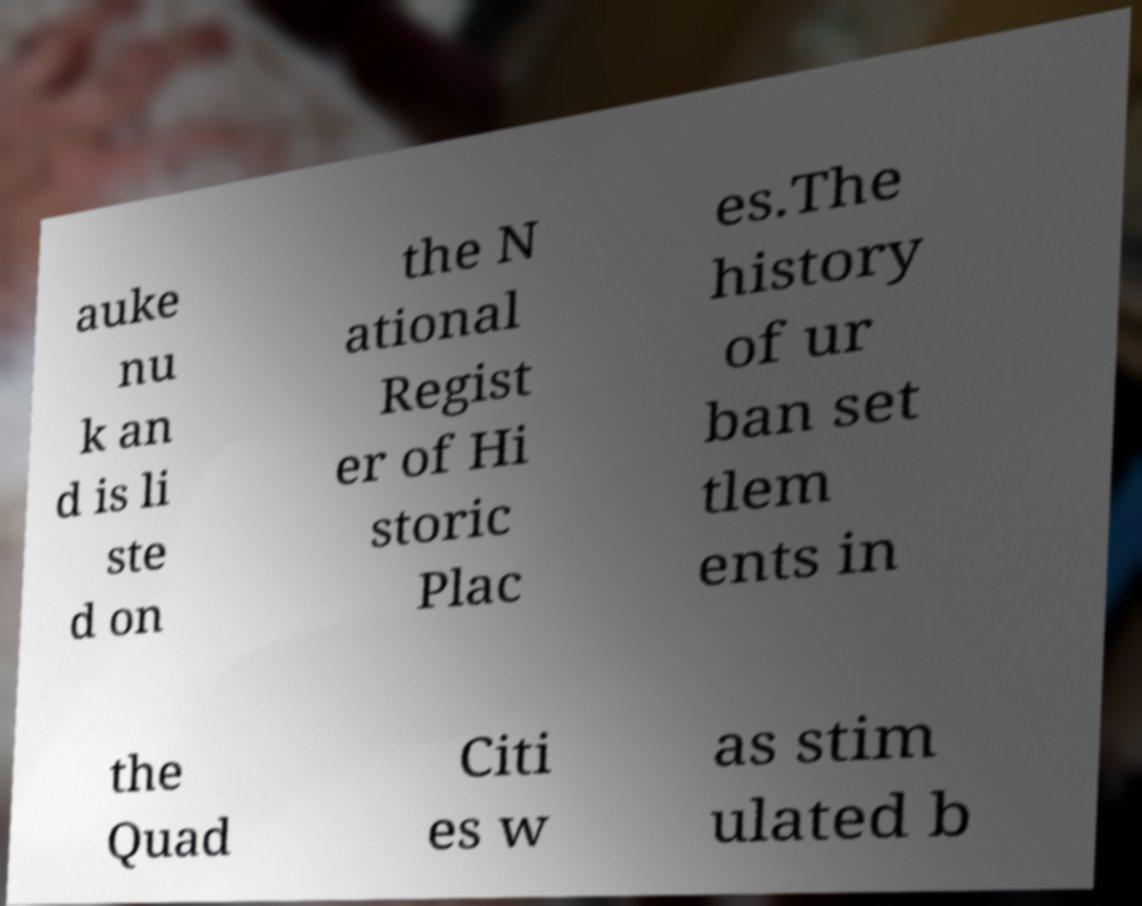For documentation purposes, I need the text within this image transcribed. Could you provide that? auke nu k an d is li ste d on the N ational Regist er of Hi storic Plac es.The history of ur ban set tlem ents in the Quad Citi es w as stim ulated b 